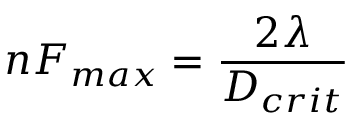<formula> <loc_0><loc_0><loc_500><loc_500>n F _ { \max } = { \frac { 2 \lambda } { D _ { c r i t } } } \,</formula> 